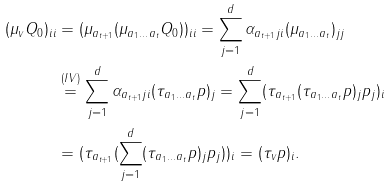Convert formula to latex. <formula><loc_0><loc_0><loc_500><loc_500>( \mu _ { v } Q _ { 0 } ) _ { i i } & = ( \mu _ { a _ { t + 1 } } ( \mu _ { a _ { 1 } \dots a _ { t } } Q _ { 0 } ) ) _ { i i } = \sum _ { j = 1 } ^ { d } \alpha _ { a _ { t + 1 } j i } ( \mu _ { a _ { 1 } \dots a _ { t } } ) _ { j j } \\ & \stackrel { ( I V ) } { = } \sum _ { j = 1 } ^ { d } \alpha _ { a _ { t + 1 } j i } ( \tau _ { a _ { 1 } \dots a _ { t } } p ) _ { j } = \sum _ { j = 1 } ^ { d } ( \tau _ { a _ { t + 1 } } ( \tau _ { a _ { 1 } \dots a _ { t } } p ) _ { j } p _ { j } ) _ { i } \\ & = ( \tau _ { a _ { t + 1 } } ( \sum _ { j = 1 } ^ { d } ( \tau _ { a _ { 1 } \dots a _ { t } } p ) _ { j } p _ { j } ) ) _ { i } = ( \tau _ { v } p ) _ { i } .</formula> 